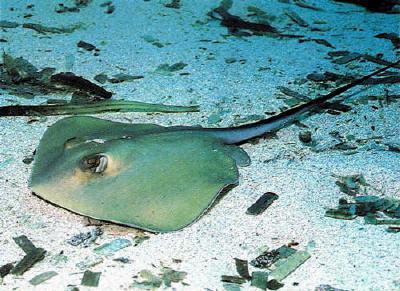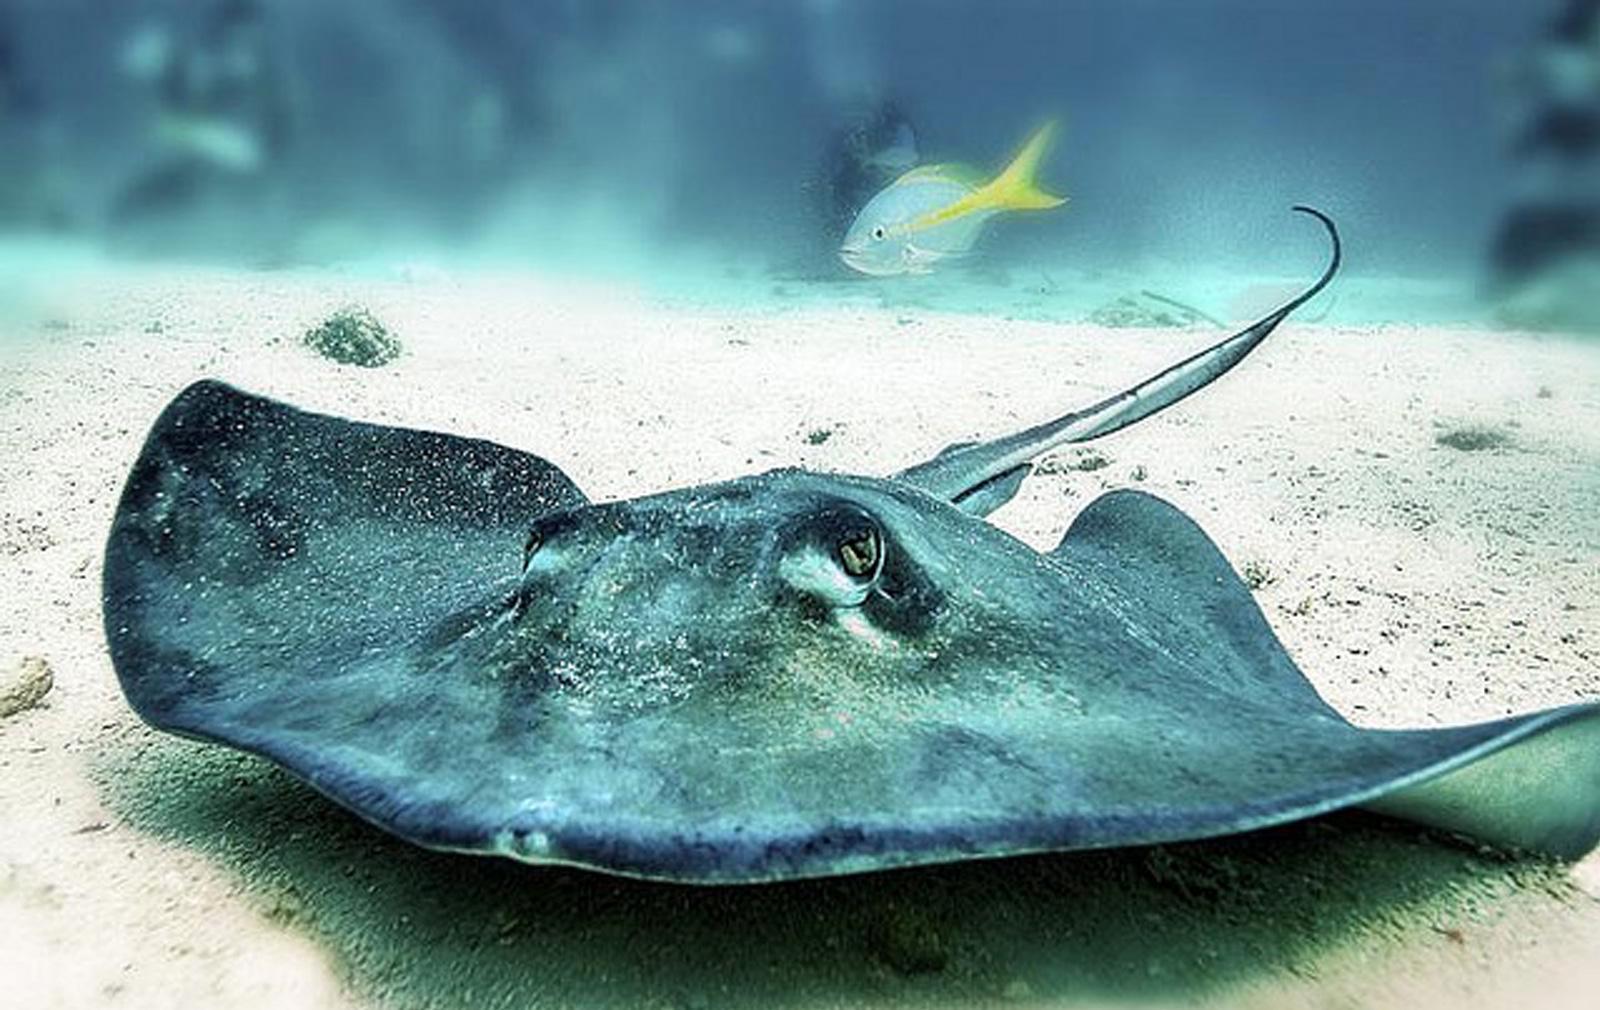The first image is the image on the left, the second image is the image on the right. Assess this claim about the two images: "Two stingray are present in the right image.". Correct or not? Answer yes or no. No. 